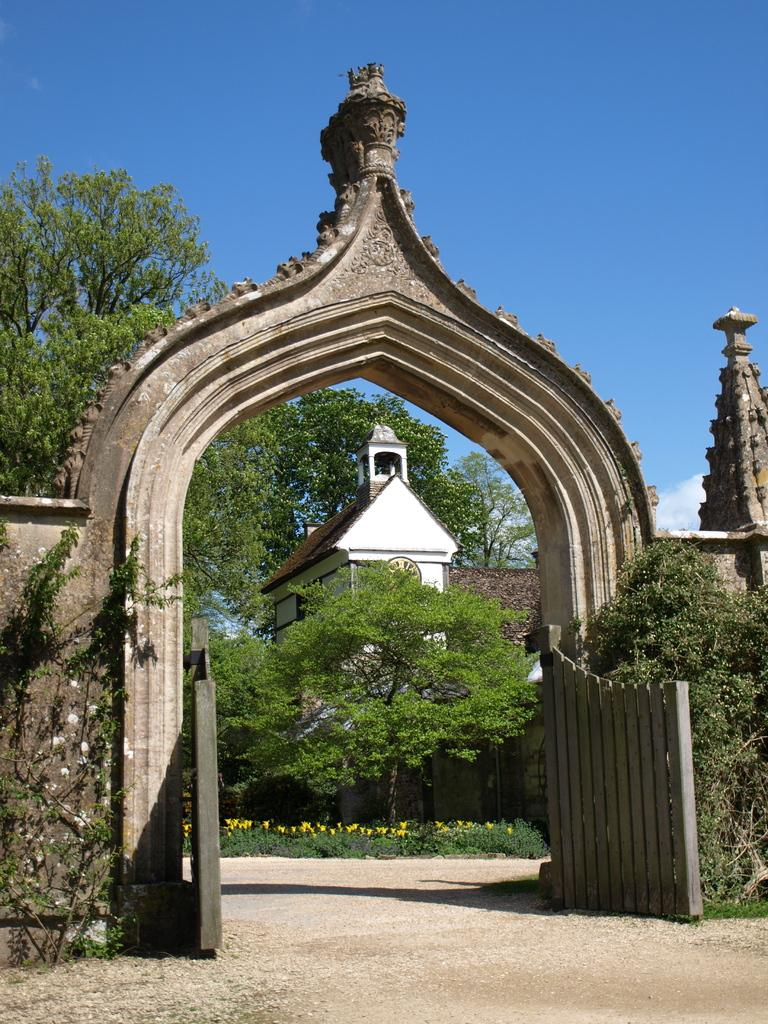What type of structure is present in the image? There is an arch in the image. What can be seen in the background of the image? There are trees, buildings, and clouds in the background of the image. How does the lock on the arch work in the image? There is no lock present on the arch in the image. 